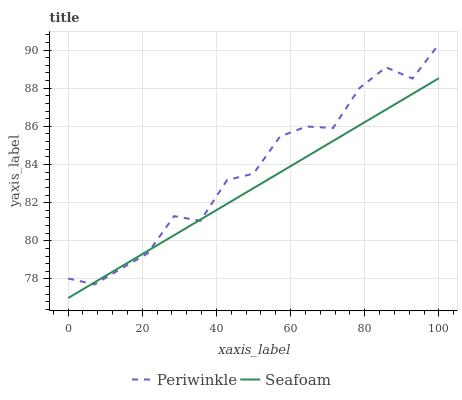Does Seafoam have the minimum area under the curve?
Answer yes or no. Yes. Does Periwinkle have the maximum area under the curve?
Answer yes or no. Yes. Does Seafoam have the maximum area under the curve?
Answer yes or no. No. Is Seafoam the smoothest?
Answer yes or no. Yes. Is Periwinkle the roughest?
Answer yes or no. Yes. Is Seafoam the roughest?
Answer yes or no. No. Does Periwinkle have the highest value?
Answer yes or no. Yes. Does Seafoam have the highest value?
Answer yes or no. No. Does Periwinkle intersect Seafoam?
Answer yes or no. Yes. Is Periwinkle less than Seafoam?
Answer yes or no. No. Is Periwinkle greater than Seafoam?
Answer yes or no. No. 